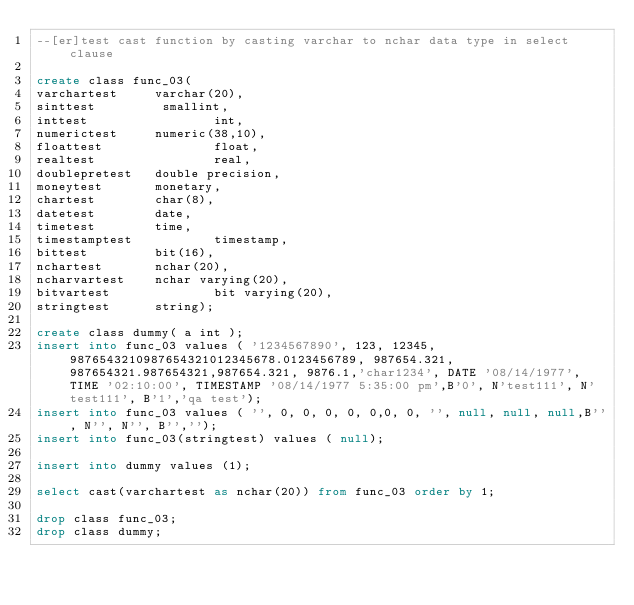<code> <loc_0><loc_0><loc_500><loc_500><_SQL_>--[er]test cast function by casting varchar to nchar data type in select clause

create class func_03(
varchartest     varchar(20),
sinttest         smallint,
inttest                 int,
numerictest     numeric(38,10),
floattest               float,
realtest                real,
doublepretest   double precision,
moneytest       monetary,
chartest        char(8),
datetest        date,
timetest        time,
timestamptest           timestamp,
bittest         bit(16),
nchartest       nchar(20),
ncharvartest    nchar varying(20),
bitvartest              bit varying(20),
stringtest      string);

create class dummy( a int );
insert into func_03 values ( '1234567890', 123, 12345, 9876543210987654321012345678.0123456789, 987654.321, 987654321.987654321,987654.321, 9876.1,'char1234', DATE '08/14/1977', TIME '02:10:00', TIMESTAMP '08/14/1977 5:35:00 pm',B'0', N'test111', N'test111', B'1','qa test');
insert into func_03 values ( '', 0, 0, 0, 0, 0,0, 0, '', null, null, null,B'', N'', N'', B'','');
insert into func_03(stringtest) values ( null);

insert into dummy values (1);

select cast(varchartest as nchar(20)) from func_03 order by 1;

drop class func_03;
drop class dummy;
</code> 